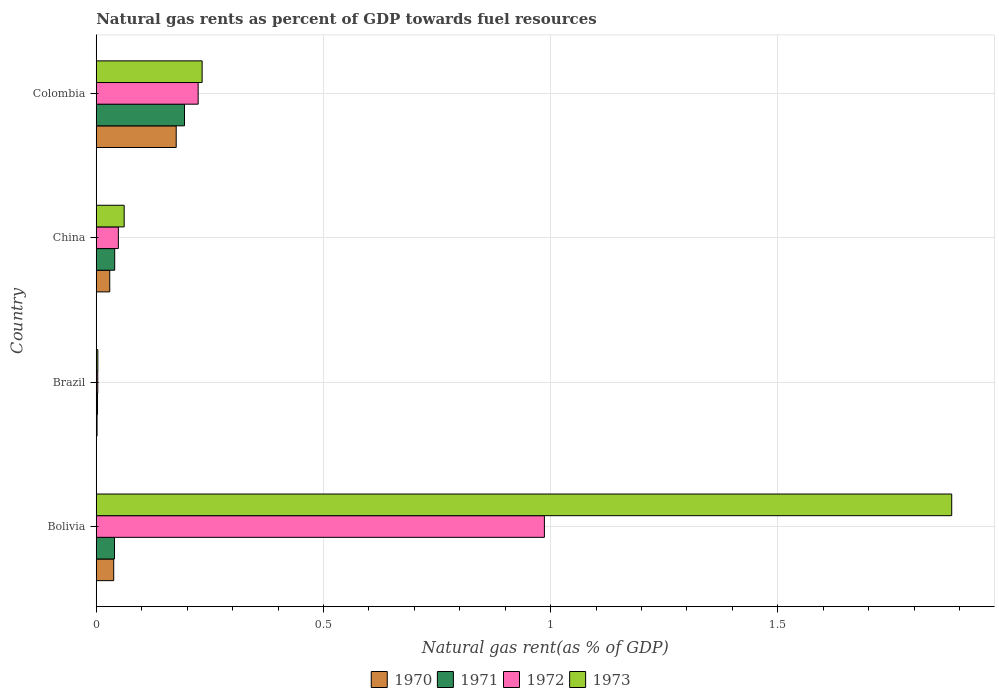How many bars are there on the 2nd tick from the top?
Your answer should be very brief. 4. In how many cases, is the number of bars for a given country not equal to the number of legend labels?
Ensure brevity in your answer.  0. What is the natural gas rent in 1970 in Brazil?
Give a very brief answer. 0. Across all countries, what is the maximum natural gas rent in 1970?
Make the answer very short. 0.18. Across all countries, what is the minimum natural gas rent in 1970?
Keep it short and to the point. 0. In which country was the natural gas rent in 1972 minimum?
Your answer should be very brief. Brazil. What is the total natural gas rent in 1970 in the graph?
Provide a short and direct response. 0.25. What is the difference between the natural gas rent in 1973 in Bolivia and that in Brazil?
Offer a terse response. 1.88. What is the difference between the natural gas rent in 1972 in Bolivia and the natural gas rent in 1970 in Colombia?
Make the answer very short. 0.81. What is the average natural gas rent in 1970 per country?
Your response must be concise. 0.06. What is the difference between the natural gas rent in 1972 and natural gas rent in 1971 in China?
Your answer should be very brief. 0.01. What is the ratio of the natural gas rent in 1970 in Bolivia to that in Colombia?
Make the answer very short. 0.22. Is the natural gas rent in 1971 in Brazil less than that in China?
Your response must be concise. Yes. What is the difference between the highest and the second highest natural gas rent in 1972?
Your response must be concise. 0.76. What is the difference between the highest and the lowest natural gas rent in 1973?
Offer a terse response. 1.88. In how many countries, is the natural gas rent in 1970 greater than the average natural gas rent in 1970 taken over all countries?
Offer a very short reply. 1. Is it the case that in every country, the sum of the natural gas rent in 1971 and natural gas rent in 1970 is greater than the sum of natural gas rent in 1972 and natural gas rent in 1973?
Your response must be concise. No. What does the 2nd bar from the top in Brazil represents?
Offer a very short reply. 1972. What does the 2nd bar from the bottom in China represents?
Provide a succinct answer. 1971. Is it the case that in every country, the sum of the natural gas rent in 1971 and natural gas rent in 1973 is greater than the natural gas rent in 1970?
Provide a short and direct response. Yes. Are the values on the major ticks of X-axis written in scientific E-notation?
Offer a very short reply. No. Does the graph contain any zero values?
Give a very brief answer. No. Does the graph contain grids?
Offer a very short reply. Yes. How are the legend labels stacked?
Keep it short and to the point. Horizontal. What is the title of the graph?
Your answer should be compact. Natural gas rents as percent of GDP towards fuel resources. Does "1970" appear as one of the legend labels in the graph?
Offer a very short reply. Yes. What is the label or title of the X-axis?
Your response must be concise. Natural gas rent(as % of GDP). What is the label or title of the Y-axis?
Provide a short and direct response. Country. What is the Natural gas rent(as % of GDP) in 1970 in Bolivia?
Give a very brief answer. 0.04. What is the Natural gas rent(as % of GDP) in 1971 in Bolivia?
Offer a terse response. 0.04. What is the Natural gas rent(as % of GDP) in 1972 in Bolivia?
Your answer should be very brief. 0.99. What is the Natural gas rent(as % of GDP) in 1973 in Bolivia?
Make the answer very short. 1.88. What is the Natural gas rent(as % of GDP) of 1970 in Brazil?
Your response must be concise. 0. What is the Natural gas rent(as % of GDP) in 1971 in Brazil?
Your response must be concise. 0. What is the Natural gas rent(as % of GDP) of 1972 in Brazil?
Your answer should be compact. 0. What is the Natural gas rent(as % of GDP) of 1973 in Brazil?
Give a very brief answer. 0. What is the Natural gas rent(as % of GDP) of 1970 in China?
Provide a succinct answer. 0.03. What is the Natural gas rent(as % of GDP) in 1971 in China?
Make the answer very short. 0.04. What is the Natural gas rent(as % of GDP) of 1972 in China?
Your answer should be very brief. 0.05. What is the Natural gas rent(as % of GDP) in 1973 in China?
Give a very brief answer. 0.06. What is the Natural gas rent(as % of GDP) in 1970 in Colombia?
Provide a short and direct response. 0.18. What is the Natural gas rent(as % of GDP) of 1971 in Colombia?
Ensure brevity in your answer.  0.19. What is the Natural gas rent(as % of GDP) of 1972 in Colombia?
Give a very brief answer. 0.22. What is the Natural gas rent(as % of GDP) of 1973 in Colombia?
Give a very brief answer. 0.23. Across all countries, what is the maximum Natural gas rent(as % of GDP) of 1970?
Make the answer very short. 0.18. Across all countries, what is the maximum Natural gas rent(as % of GDP) in 1971?
Make the answer very short. 0.19. Across all countries, what is the maximum Natural gas rent(as % of GDP) in 1972?
Keep it short and to the point. 0.99. Across all countries, what is the maximum Natural gas rent(as % of GDP) of 1973?
Offer a very short reply. 1.88. Across all countries, what is the minimum Natural gas rent(as % of GDP) in 1970?
Provide a short and direct response. 0. Across all countries, what is the minimum Natural gas rent(as % of GDP) in 1971?
Your answer should be compact. 0. Across all countries, what is the minimum Natural gas rent(as % of GDP) in 1972?
Keep it short and to the point. 0. Across all countries, what is the minimum Natural gas rent(as % of GDP) of 1973?
Give a very brief answer. 0. What is the total Natural gas rent(as % of GDP) of 1970 in the graph?
Provide a succinct answer. 0.25. What is the total Natural gas rent(as % of GDP) of 1971 in the graph?
Provide a succinct answer. 0.28. What is the total Natural gas rent(as % of GDP) in 1972 in the graph?
Ensure brevity in your answer.  1.26. What is the total Natural gas rent(as % of GDP) in 1973 in the graph?
Offer a very short reply. 2.18. What is the difference between the Natural gas rent(as % of GDP) in 1970 in Bolivia and that in Brazil?
Offer a very short reply. 0.04. What is the difference between the Natural gas rent(as % of GDP) in 1971 in Bolivia and that in Brazil?
Your answer should be very brief. 0.04. What is the difference between the Natural gas rent(as % of GDP) of 1973 in Bolivia and that in Brazil?
Provide a short and direct response. 1.88. What is the difference between the Natural gas rent(as % of GDP) in 1970 in Bolivia and that in China?
Your answer should be compact. 0.01. What is the difference between the Natural gas rent(as % of GDP) of 1971 in Bolivia and that in China?
Your answer should be very brief. -0. What is the difference between the Natural gas rent(as % of GDP) in 1972 in Bolivia and that in China?
Make the answer very short. 0.94. What is the difference between the Natural gas rent(as % of GDP) in 1973 in Bolivia and that in China?
Ensure brevity in your answer.  1.82. What is the difference between the Natural gas rent(as % of GDP) of 1970 in Bolivia and that in Colombia?
Make the answer very short. -0.14. What is the difference between the Natural gas rent(as % of GDP) in 1971 in Bolivia and that in Colombia?
Give a very brief answer. -0.15. What is the difference between the Natural gas rent(as % of GDP) in 1972 in Bolivia and that in Colombia?
Provide a short and direct response. 0.76. What is the difference between the Natural gas rent(as % of GDP) of 1973 in Bolivia and that in Colombia?
Your answer should be compact. 1.65. What is the difference between the Natural gas rent(as % of GDP) of 1970 in Brazil and that in China?
Your answer should be very brief. -0.03. What is the difference between the Natural gas rent(as % of GDP) in 1971 in Brazil and that in China?
Keep it short and to the point. -0.04. What is the difference between the Natural gas rent(as % of GDP) in 1972 in Brazil and that in China?
Give a very brief answer. -0.05. What is the difference between the Natural gas rent(as % of GDP) of 1973 in Brazil and that in China?
Provide a succinct answer. -0.06. What is the difference between the Natural gas rent(as % of GDP) in 1970 in Brazil and that in Colombia?
Offer a very short reply. -0.17. What is the difference between the Natural gas rent(as % of GDP) in 1971 in Brazil and that in Colombia?
Ensure brevity in your answer.  -0.19. What is the difference between the Natural gas rent(as % of GDP) of 1972 in Brazil and that in Colombia?
Provide a short and direct response. -0.22. What is the difference between the Natural gas rent(as % of GDP) of 1973 in Brazil and that in Colombia?
Provide a succinct answer. -0.23. What is the difference between the Natural gas rent(as % of GDP) of 1970 in China and that in Colombia?
Provide a short and direct response. -0.15. What is the difference between the Natural gas rent(as % of GDP) in 1971 in China and that in Colombia?
Ensure brevity in your answer.  -0.15. What is the difference between the Natural gas rent(as % of GDP) of 1972 in China and that in Colombia?
Keep it short and to the point. -0.18. What is the difference between the Natural gas rent(as % of GDP) in 1973 in China and that in Colombia?
Offer a very short reply. -0.17. What is the difference between the Natural gas rent(as % of GDP) of 1970 in Bolivia and the Natural gas rent(as % of GDP) of 1971 in Brazil?
Your response must be concise. 0.04. What is the difference between the Natural gas rent(as % of GDP) of 1970 in Bolivia and the Natural gas rent(as % of GDP) of 1972 in Brazil?
Offer a very short reply. 0.04. What is the difference between the Natural gas rent(as % of GDP) of 1970 in Bolivia and the Natural gas rent(as % of GDP) of 1973 in Brazil?
Ensure brevity in your answer.  0.03. What is the difference between the Natural gas rent(as % of GDP) in 1971 in Bolivia and the Natural gas rent(as % of GDP) in 1972 in Brazil?
Provide a succinct answer. 0.04. What is the difference between the Natural gas rent(as % of GDP) in 1971 in Bolivia and the Natural gas rent(as % of GDP) in 1973 in Brazil?
Keep it short and to the point. 0.04. What is the difference between the Natural gas rent(as % of GDP) of 1972 in Bolivia and the Natural gas rent(as % of GDP) of 1973 in Brazil?
Ensure brevity in your answer.  0.98. What is the difference between the Natural gas rent(as % of GDP) in 1970 in Bolivia and the Natural gas rent(as % of GDP) in 1971 in China?
Your answer should be very brief. -0. What is the difference between the Natural gas rent(as % of GDP) of 1970 in Bolivia and the Natural gas rent(as % of GDP) of 1972 in China?
Ensure brevity in your answer.  -0.01. What is the difference between the Natural gas rent(as % of GDP) of 1970 in Bolivia and the Natural gas rent(as % of GDP) of 1973 in China?
Give a very brief answer. -0.02. What is the difference between the Natural gas rent(as % of GDP) of 1971 in Bolivia and the Natural gas rent(as % of GDP) of 1972 in China?
Offer a very short reply. -0.01. What is the difference between the Natural gas rent(as % of GDP) of 1971 in Bolivia and the Natural gas rent(as % of GDP) of 1973 in China?
Provide a short and direct response. -0.02. What is the difference between the Natural gas rent(as % of GDP) in 1972 in Bolivia and the Natural gas rent(as % of GDP) in 1973 in China?
Offer a very short reply. 0.92. What is the difference between the Natural gas rent(as % of GDP) of 1970 in Bolivia and the Natural gas rent(as % of GDP) of 1971 in Colombia?
Keep it short and to the point. -0.16. What is the difference between the Natural gas rent(as % of GDP) in 1970 in Bolivia and the Natural gas rent(as % of GDP) in 1972 in Colombia?
Keep it short and to the point. -0.19. What is the difference between the Natural gas rent(as % of GDP) in 1970 in Bolivia and the Natural gas rent(as % of GDP) in 1973 in Colombia?
Keep it short and to the point. -0.19. What is the difference between the Natural gas rent(as % of GDP) in 1971 in Bolivia and the Natural gas rent(as % of GDP) in 1972 in Colombia?
Your answer should be compact. -0.18. What is the difference between the Natural gas rent(as % of GDP) of 1971 in Bolivia and the Natural gas rent(as % of GDP) of 1973 in Colombia?
Make the answer very short. -0.19. What is the difference between the Natural gas rent(as % of GDP) in 1972 in Bolivia and the Natural gas rent(as % of GDP) in 1973 in Colombia?
Your answer should be very brief. 0.75. What is the difference between the Natural gas rent(as % of GDP) in 1970 in Brazil and the Natural gas rent(as % of GDP) in 1971 in China?
Ensure brevity in your answer.  -0.04. What is the difference between the Natural gas rent(as % of GDP) of 1970 in Brazil and the Natural gas rent(as % of GDP) of 1972 in China?
Your response must be concise. -0.05. What is the difference between the Natural gas rent(as % of GDP) of 1970 in Brazil and the Natural gas rent(as % of GDP) of 1973 in China?
Your response must be concise. -0.06. What is the difference between the Natural gas rent(as % of GDP) in 1971 in Brazil and the Natural gas rent(as % of GDP) in 1972 in China?
Ensure brevity in your answer.  -0.05. What is the difference between the Natural gas rent(as % of GDP) in 1971 in Brazil and the Natural gas rent(as % of GDP) in 1973 in China?
Keep it short and to the point. -0.06. What is the difference between the Natural gas rent(as % of GDP) of 1972 in Brazil and the Natural gas rent(as % of GDP) of 1973 in China?
Your response must be concise. -0.06. What is the difference between the Natural gas rent(as % of GDP) in 1970 in Brazil and the Natural gas rent(as % of GDP) in 1971 in Colombia?
Give a very brief answer. -0.19. What is the difference between the Natural gas rent(as % of GDP) of 1970 in Brazil and the Natural gas rent(as % of GDP) of 1972 in Colombia?
Ensure brevity in your answer.  -0.22. What is the difference between the Natural gas rent(as % of GDP) of 1970 in Brazil and the Natural gas rent(as % of GDP) of 1973 in Colombia?
Your answer should be compact. -0.23. What is the difference between the Natural gas rent(as % of GDP) in 1971 in Brazil and the Natural gas rent(as % of GDP) in 1972 in Colombia?
Offer a very short reply. -0.22. What is the difference between the Natural gas rent(as % of GDP) of 1971 in Brazil and the Natural gas rent(as % of GDP) of 1973 in Colombia?
Give a very brief answer. -0.23. What is the difference between the Natural gas rent(as % of GDP) of 1972 in Brazil and the Natural gas rent(as % of GDP) of 1973 in Colombia?
Keep it short and to the point. -0.23. What is the difference between the Natural gas rent(as % of GDP) of 1970 in China and the Natural gas rent(as % of GDP) of 1971 in Colombia?
Your response must be concise. -0.16. What is the difference between the Natural gas rent(as % of GDP) of 1970 in China and the Natural gas rent(as % of GDP) of 1972 in Colombia?
Ensure brevity in your answer.  -0.19. What is the difference between the Natural gas rent(as % of GDP) of 1970 in China and the Natural gas rent(as % of GDP) of 1973 in Colombia?
Make the answer very short. -0.2. What is the difference between the Natural gas rent(as % of GDP) in 1971 in China and the Natural gas rent(as % of GDP) in 1972 in Colombia?
Provide a short and direct response. -0.18. What is the difference between the Natural gas rent(as % of GDP) in 1971 in China and the Natural gas rent(as % of GDP) in 1973 in Colombia?
Offer a very short reply. -0.19. What is the difference between the Natural gas rent(as % of GDP) of 1972 in China and the Natural gas rent(as % of GDP) of 1973 in Colombia?
Your answer should be compact. -0.18. What is the average Natural gas rent(as % of GDP) of 1970 per country?
Your answer should be compact. 0.06. What is the average Natural gas rent(as % of GDP) of 1971 per country?
Offer a terse response. 0.07. What is the average Natural gas rent(as % of GDP) of 1972 per country?
Keep it short and to the point. 0.32. What is the average Natural gas rent(as % of GDP) in 1973 per country?
Your answer should be compact. 0.55. What is the difference between the Natural gas rent(as % of GDP) of 1970 and Natural gas rent(as % of GDP) of 1971 in Bolivia?
Make the answer very short. -0. What is the difference between the Natural gas rent(as % of GDP) in 1970 and Natural gas rent(as % of GDP) in 1972 in Bolivia?
Your response must be concise. -0.95. What is the difference between the Natural gas rent(as % of GDP) in 1970 and Natural gas rent(as % of GDP) in 1973 in Bolivia?
Offer a terse response. -1.84. What is the difference between the Natural gas rent(as % of GDP) in 1971 and Natural gas rent(as % of GDP) in 1972 in Bolivia?
Keep it short and to the point. -0.95. What is the difference between the Natural gas rent(as % of GDP) of 1971 and Natural gas rent(as % of GDP) of 1973 in Bolivia?
Offer a terse response. -1.84. What is the difference between the Natural gas rent(as % of GDP) in 1972 and Natural gas rent(as % of GDP) in 1973 in Bolivia?
Your answer should be compact. -0.9. What is the difference between the Natural gas rent(as % of GDP) of 1970 and Natural gas rent(as % of GDP) of 1971 in Brazil?
Your answer should be very brief. -0. What is the difference between the Natural gas rent(as % of GDP) in 1970 and Natural gas rent(as % of GDP) in 1972 in Brazil?
Keep it short and to the point. -0. What is the difference between the Natural gas rent(as % of GDP) in 1970 and Natural gas rent(as % of GDP) in 1973 in Brazil?
Offer a terse response. -0. What is the difference between the Natural gas rent(as % of GDP) of 1971 and Natural gas rent(as % of GDP) of 1972 in Brazil?
Offer a very short reply. -0. What is the difference between the Natural gas rent(as % of GDP) in 1971 and Natural gas rent(as % of GDP) in 1973 in Brazil?
Make the answer very short. -0. What is the difference between the Natural gas rent(as % of GDP) in 1972 and Natural gas rent(as % of GDP) in 1973 in Brazil?
Give a very brief answer. -0. What is the difference between the Natural gas rent(as % of GDP) of 1970 and Natural gas rent(as % of GDP) of 1971 in China?
Your response must be concise. -0.01. What is the difference between the Natural gas rent(as % of GDP) of 1970 and Natural gas rent(as % of GDP) of 1972 in China?
Offer a terse response. -0.02. What is the difference between the Natural gas rent(as % of GDP) of 1970 and Natural gas rent(as % of GDP) of 1973 in China?
Offer a terse response. -0.03. What is the difference between the Natural gas rent(as % of GDP) of 1971 and Natural gas rent(as % of GDP) of 1972 in China?
Provide a succinct answer. -0.01. What is the difference between the Natural gas rent(as % of GDP) of 1971 and Natural gas rent(as % of GDP) of 1973 in China?
Your response must be concise. -0.02. What is the difference between the Natural gas rent(as % of GDP) of 1972 and Natural gas rent(as % of GDP) of 1973 in China?
Make the answer very short. -0.01. What is the difference between the Natural gas rent(as % of GDP) of 1970 and Natural gas rent(as % of GDP) of 1971 in Colombia?
Provide a short and direct response. -0.02. What is the difference between the Natural gas rent(as % of GDP) of 1970 and Natural gas rent(as % of GDP) of 1972 in Colombia?
Offer a very short reply. -0.05. What is the difference between the Natural gas rent(as % of GDP) of 1970 and Natural gas rent(as % of GDP) of 1973 in Colombia?
Give a very brief answer. -0.06. What is the difference between the Natural gas rent(as % of GDP) of 1971 and Natural gas rent(as % of GDP) of 1972 in Colombia?
Ensure brevity in your answer.  -0.03. What is the difference between the Natural gas rent(as % of GDP) of 1971 and Natural gas rent(as % of GDP) of 1973 in Colombia?
Offer a terse response. -0.04. What is the difference between the Natural gas rent(as % of GDP) in 1972 and Natural gas rent(as % of GDP) in 1973 in Colombia?
Give a very brief answer. -0.01. What is the ratio of the Natural gas rent(as % of GDP) of 1970 in Bolivia to that in Brazil?
Ensure brevity in your answer.  21.58. What is the ratio of the Natural gas rent(as % of GDP) of 1971 in Bolivia to that in Brazil?
Make the answer very short. 14.62. What is the ratio of the Natural gas rent(as % of GDP) in 1972 in Bolivia to that in Brazil?
Offer a terse response. 297.41. What is the ratio of the Natural gas rent(as % of GDP) in 1973 in Bolivia to that in Brazil?
Give a very brief answer. 539.46. What is the ratio of the Natural gas rent(as % of GDP) of 1970 in Bolivia to that in China?
Make the answer very short. 1.3. What is the ratio of the Natural gas rent(as % of GDP) in 1971 in Bolivia to that in China?
Provide a short and direct response. 0.99. What is the ratio of the Natural gas rent(as % of GDP) of 1972 in Bolivia to that in China?
Your answer should be compact. 20.28. What is the ratio of the Natural gas rent(as % of GDP) of 1973 in Bolivia to that in China?
Make the answer very short. 30.65. What is the ratio of the Natural gas rent(as % of GDP) in 1970 in Bolivia to that in Colombia?
Offer a very short reply. 0.22. What is the ratio of the Natural gas rent(as % of GDP) of 1971 in Bolivia to that in Colombia?
Give a very brief answer. 0.21. What is the ratio of the Natural gas rent(as % of GDP) in 1972 in Bolivia to that in Colombia?
Offer a very short reply. 4.4. What is the ratio of the Natural gas rent(as % of GDP) of 1973 in Bolivia to that in Colombia?
Your answer should be very brief. 8.08. What is the ratio of the Natural gas rent(as % of GDP) in 1970 in Brazil to that in China?
Keep it short and to the point. 0.06. What is the ratio of the Natural gas rent(as % of GDP) in 1971 in Brazil to that in China?
Make the answer very short. 0.07. What is the ratio of the Natural gas rent(as % of GDP) of 1972 in Brazil to that in China?
Offer a very short reply. 0.07. What is the ratio of the Natural gas rent(as % of GDP) in 1973 in Brazil to that in China?
Provide a short and direct response. 0.06. What is the ratio of the Natural gas rent(as % of GDP) in 1970 in Brazil to that in Colombia?
Give a very brief answer. 0.01. What is the ratio of the Natural gas rent(as % of GDP) of 1971 in Brazil to that in Colombia?
Keep it short and to the point. 0.01. What is the ratio of the Natural gas rent(as % of GDP) of 1972 in Brazil to that in Colombia?
Your answer should be compact. 0.01. What is the ratio of the Natural gas rent(as % of GDP) in 1973 in Brazil to that in Colombia?
Offer a very short reply. 0.01. What is the ratio of the Natural gas rent(as % of GDP) of 1970 in China to that in Colombia?
Ensure brevity in your answer.  0.17. What is the ratio of the Natural gas rent(as % of GDP) of 1971 in China to that in Colombia?
Give a very brief answer. 0.21. What is the ratio of the Natural gas rent(as % of GDP) in 1972 in China to that in Colombia?
Make the answer very short. 0.22. What is the ratio of the Natural gas rent(as % of GDP) of 1973 in China to that in Colombia?
Your answer should be very brief. 0.26. What is the difference between the highest and the second highest Natural gas rent(as % of GDP) in 1970?
Provide a succinct answer. 0.14. What is the difference between the highest and the second highest Natural gas rent(as % of GDP) of 1971?
Keep it short and to the point. 0.15. What is the difference between the highest and the second highest Natural gas rent(as % of GDP) in 1972?
Offer a terse response. 0.76. What is the difference between the highest and the second highest Natural gas rent(as % of GDP) of 1973?
Your answer should be compact. 1.65. What is the difference between the highest and the lowest Natural gas rent(as % of GDP) in 1970?
Your answer should be compact. 0.17. What is the difference between the highest and the lowest Natural gas rent(as % of GDP) in 1971?
Make the answer very short. 0.19. What is the difference between the highest and the lowest Natural gas rent(as % of GDP) of 1972?
Give a very brief answer. 0.98. What is the difference between the highest and the lowest Natural gas rent(as % of GDP) in 1973?
Provide a succinct answer. 1.88. 